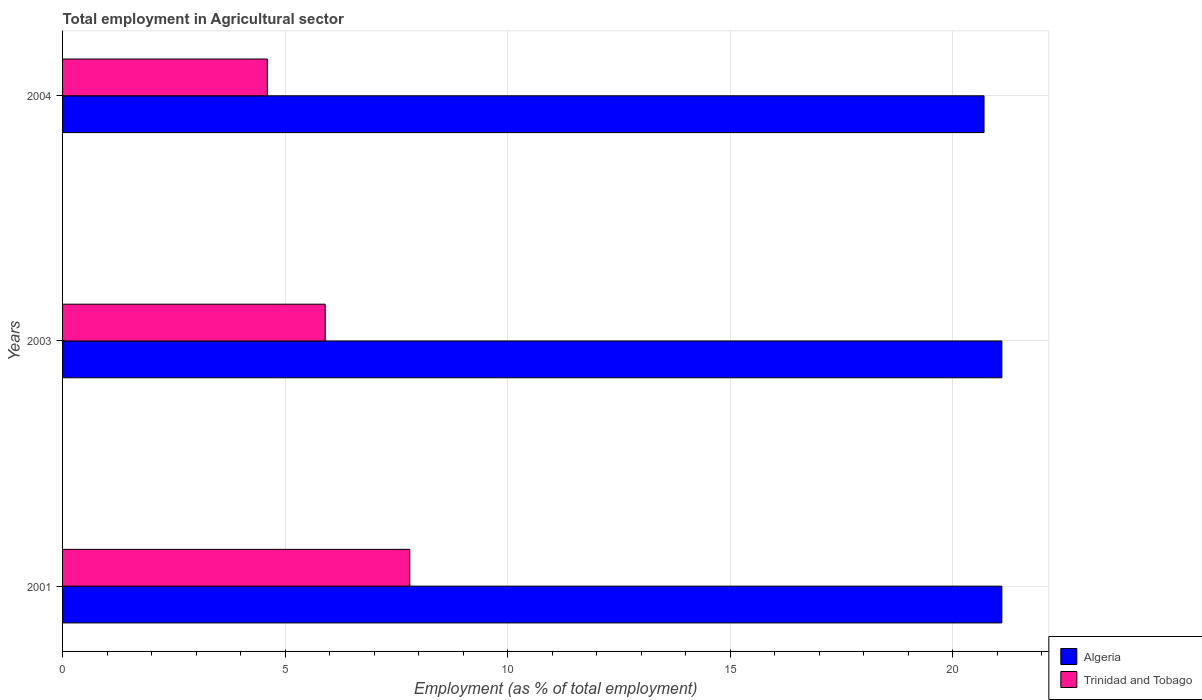Are the number of bars per tick equal to the number of legend labels?
Provide a succinct answer. Yes. In how many cases, is the number of bars for a given year not equal to the number of legend labels?
Make the answer very short. 0. What is the employment in agricultural sector in Algeria in 2003?
Provide a short and direct response. 21.1. Across all years, what is the maximum employment in agricultural sector in Trinidad and Tobago?
Make the answer very short. 7.8. Across all years, what is the minimum employment in agricultural sector in Algeria?
Make the answer very short. 20.7. In which year was the employment in agricultural sector in Algeria maximum?
Offer a terse response. 2001. In which year was the employment in agricultural sector in Trinidad and Tobago minimum?
Keep it short and to the point. 2004. What is the total employment in agricultural sector in Algeria in the graph?
Offer a terse response. 62.9. What is the difference between the employment in agricultural sector in Trinidad and Tobago in 2001 and that in 2003?
Keep it short and to the point. 1.9. What is the difference between the employment in agricultural sector in Trinidad and Tobago in 2004 and the employment in agricultural sector in Algeria in 2001?
Make the answer very short. -16.5. What is the average employment in agricultural sector in Trinidad and Tobago per year?
Keep it short and to the point. 6.1. In the year 2003, what is the difference between the employment in agricultural sector in Trinidad and Tobago and employment in agricultural sector in Algeria?
Offer a very short reply. -15.2. What is the ratio of the employment in agricultural sector in Trinidad and Tobago in 2003 to that in 2004?
Your response must be concise. 1.28. Is the difference between the employment in agricultural sector in Trinidad and Tobago in 2001 and 2003 greater than the difference between the employment in agricultural sector in Algeria in 2001 and 2003?
Your response must be concise. Yes. What is the difference between the highest and the second highest employment in agricultural sector in Algeria?
Provide a succinct answer. 0. What is the difference between the highest and the lowest employment in agricultural sector in Algeria?
Your answer should be very brief. 0.4. What does the 1st bar from the top in 2001 represents?
Your answer should be compact. Trinidad and Tobago. What does the 2nd bar from the bottom in 2001 represents?
Ensure brevity in your answer.  Trinidad and Tobago. How many years are there in the graph?
Offer a terse response. 3. What is the difference between two consecutive major ticks on the X-axis?
Give a very brief answer. 5. Does the graph contain any zero values?
Your response must be concise. No. How are the legend labels stacked?
Give a very brief answer. Vertical. What is the title of the graph?
Make the answer very short. Total employment in Agricultural sector. Does "Pakistan" appear as one of the legend labels in the graph?
Your response must be concise. No. What is the label or title of the X-axis?
Your response must be concise. Employment (as % of total employment). What is the Employment (as % of total employment) in Algeria in 2001?
Give a very brief answer. 21.1. What is the Employment (as % of total employment) of Trinidad and Tobago in 2001?
Offer a very short reply. 7.8. What is the Employment (as % of total employment) in Algeria in 2003?
Your answer should be compact. 21.1. What is the Employment (as % of total employment) in Trinidad and Tobago in 2003?
Give a very brief answer. 5.9. What is the Employment (as % of total employment) in Algeria in 2004?
Keep it short and to the point. 20.7. What is the Employment (as % of total employment) of Trinidad and Tobago in 2004?
Keep it short and to the point. 4.6. Across all years, what is the maximum Employment (as % of total employment) of Algeria?
Provide a succinct answer. 21.1. Across all years, what is the maximum Employment (as % of total employment) of Trinidad and Tobago?
Provide a succinct answer. 7.8. Across all years, what is the minimum Employment (as % of total employment) in Algeria?
Ensure brevity in your answer.  20.7. Across all years, what is the minimum Employment (as % of total employment) of Trinidad and Tobago?
Ensure brevity in your answer.  4.6. What is the total Employment (as % of total employment) of Algeria in the graph?
Your answer should be very brief. 62.9. What is the difference between the Employment (as % of total employment) in Trinidad and Tobago in 2001 and that in 2004?
Ensure brevity in your answer.  3.2. What is the difference between the Employment (as % of total employment) of Algeria in 2003 and that in 2004?
Ensure brevity in your answer.  0.4. What is the difference between the Employment (as % of total employment) of Algeria in 2001 and the Employment (as % of total employment) of Trinidad and Tobago in 2003?
Your answer should be compact. 15.2. What is the difference between the Employment (as % of total employment) in Algeria in 2001 and the Employment (as % of total employment) in Trinidad and Tobago in 2004?
Your answer should be very brief. 16.5. What is the average Employment (as % of total employment) of Algeria per year?
Provide a succinct answer. 20.97. What is the average Employment (as % of total employment) of Trinidad and Tobago per year?
Ensure brevity in your answer.  6.1. In the year 2001, what is the difference between the Employment (as % of total employment) in Algeria and Employment (as % of total employment) in Trinidad and Tobago?
Offer a very short reply. 13.3. In the year 2003, what is the difference between the Employment (as % of total employment) in Algeria and Employment (as % of total employment) in Trinidad and Tobago?
Offer a terse response. 15.2. In the year 2004, what is the difference between the Employment (as % of total employment) in Algeria and Employment (as % of total employment) in Trinidad and Tobago?
Provide a short and direct response. 16.1. What is the ratio of the Employment (as % of total employment) of Trinidad and Tobago in 2001 to that in 2003?
Your response must be concise. 1.32. What is the ratio of the Employment (as % of total employment) of Algeria in 2001 to that in 2004?
Keep it short and to the point. 1.02. What is the ratio of the Employment (as % of total employment) in Trinidad and Tobago in 2001 to that in 2004?
Ensure brevity in your answer.  1.7. What is the ratio of the Employment (as % of total employment) in Algeria in 2003 to that in 2004?
Offer a terse response. 1.02. What is the ratio of the Employment (as % of total employment) of Trinidad and Tobago in 2003 to that in 2004?
Your answer should be compact. 1.28. What is the difference between the highest and the second highest Employment (as % of total employment) in Algeria?
Your response must be concise. 0. What is the difference between the highest and the lowest Employment (as % of total employment) of Algeria?
Provide a succinct answer. 0.4. What is the difference between the highest and the lowest Employment (as % of total employment) of Trinidad and Tobago?
Make the answer very short. 3.2. 